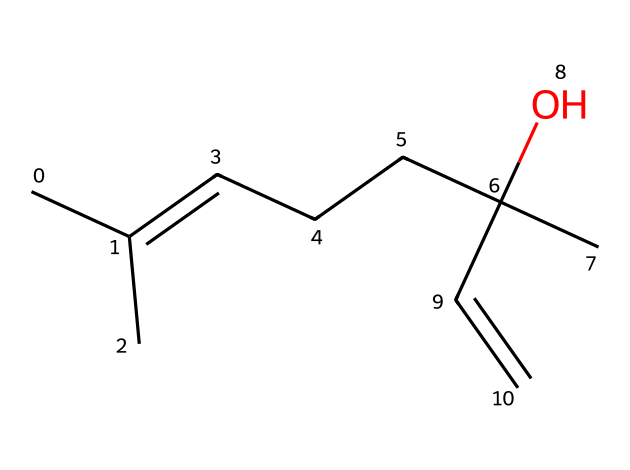What is the molecular formula of linalool? To determine the molecular formula from the SMILES representation, we need to count the number of each type of atom present. The SMILES indicates carbon (C) and oxygen (O) atoms. Counting gives us 10 carbon atoms, 18 hydrogen atoms, and 1 oxygen atom, leading to the molecular formula C10H18O.
Answer: C10H18O How many double bonds are present in linalool? By analyzing the SMILES structure, we can identify the presence of double bonds. The structure contains two carbon-carbon double bonds, recognized by the "=" symbols in the SMILES notation.
Answer: 2 What functional group is present in linalool? The presence of an oxygen atom bonded to a carbon atom indicates the existence of a hydroxyl group (–OH), which is characteristic of alcohols. This can be inferred from the "C(C)(O)" portion in the SMILES.
Answer: hydroxyl group How many stereocenters does linalool have? To find the number of stereocenters, we need to identify carbon atoms bonded to four distinct substituents. The structure has one such carbon atom in the branched section around the oxygen, making it a stereocenter.
Answer: 1 Is linalool saturated or unsaturated? Unsaturation can be evaluated by looking at the number of double bonds. Since linalool contains double bonds, which denote unsaturation, we conclude that it is an unsaturated compound.
Answer: unsaturated What is the major scent characteristic of linalool? Linalool is known for its floral scent, which can be inferred from its common sources like lavender. The overall structure supports the perception of floral characteristics.
Answer: floral scent 